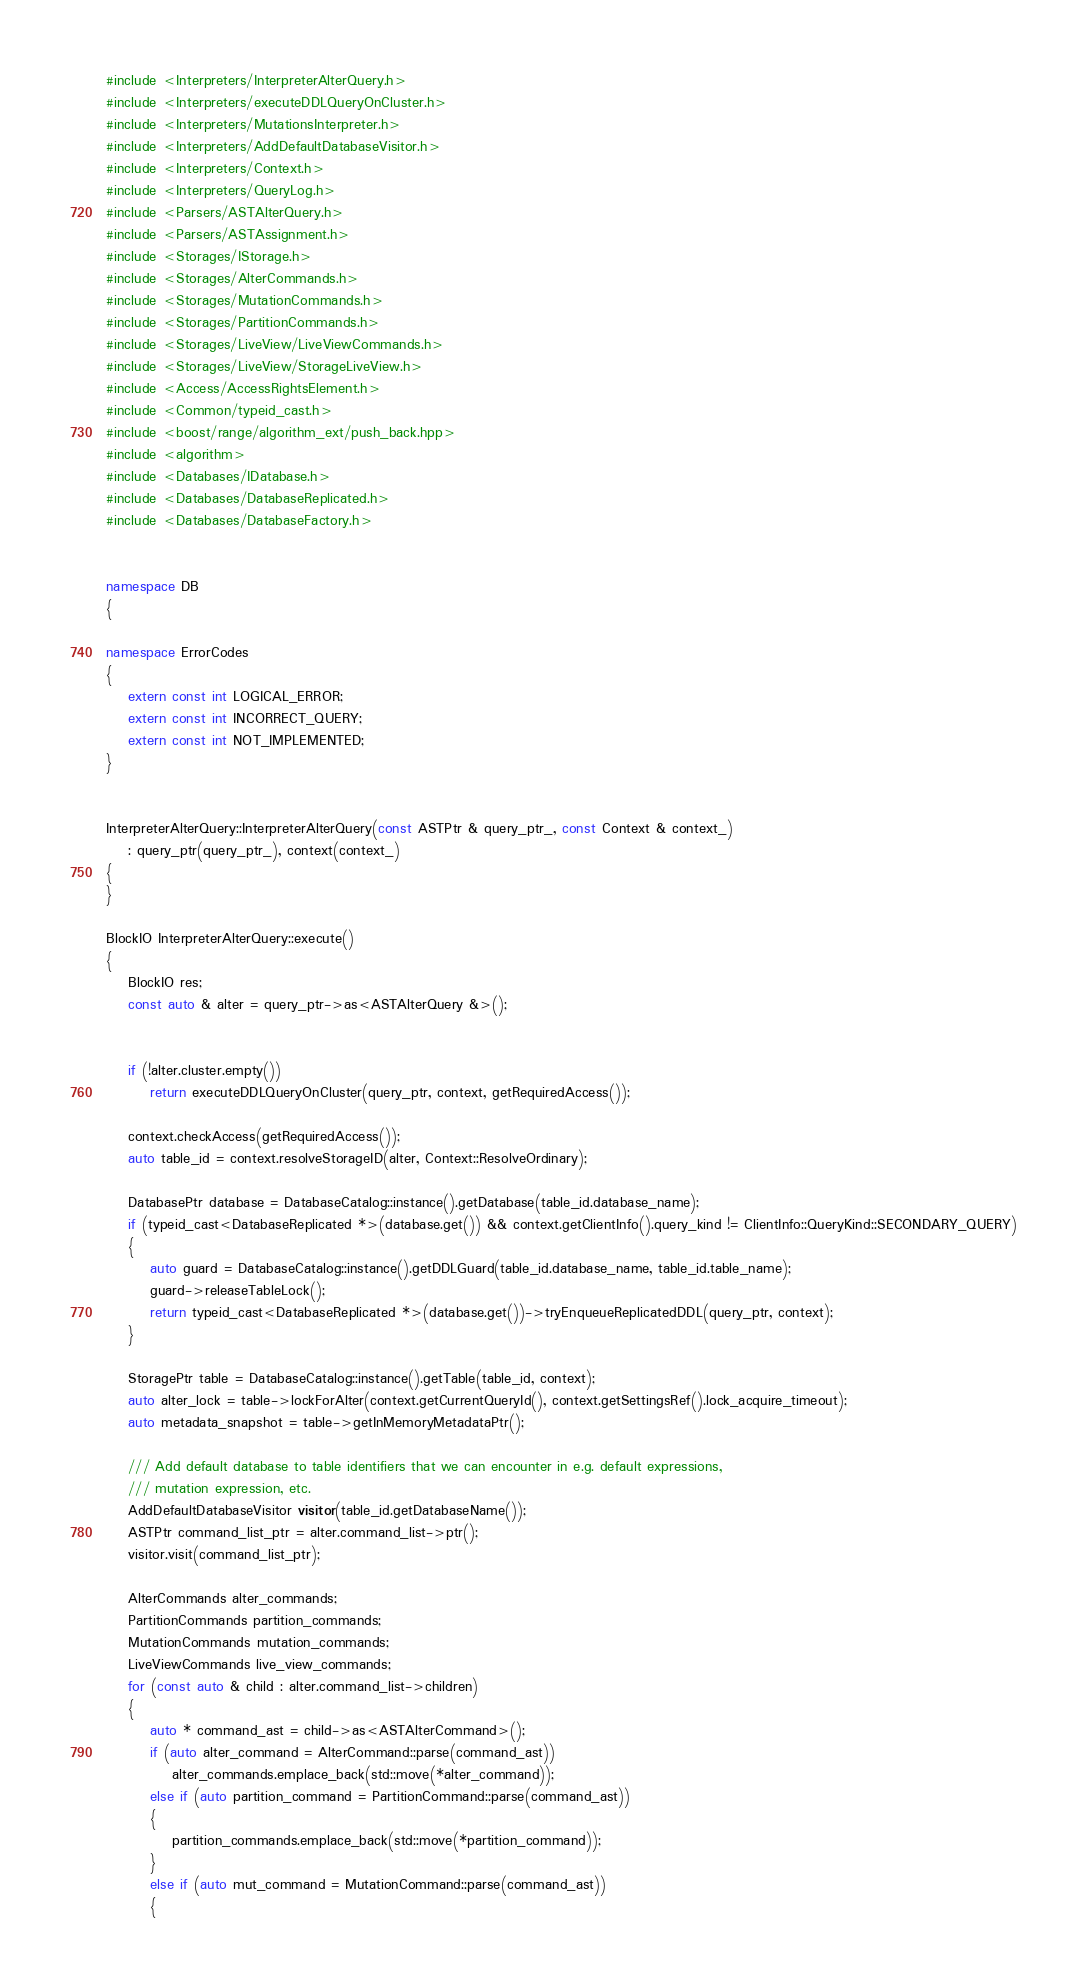Convert code to text. <code><loc_0><loc_0><loc_500><loc_500><_C++_>#include <Interpreters/InterpreterAlterQuery.h>
#include <Interpreters/executeDDLQueryOnCluster.h>
#include <Interpreters/MutationsInterpreter.h>
#include <Interpreters/AddDefaultDatabaseVisitor.h>
#include <Interpreters/Context.h>
#include <Interpreters/QueryLog.h>
#include <Parsers/ASTAlterQuery.h>
#include <Parsers/ASTAssignment.h>
#include <Storages/IStorage.h>
#include <Storages/AlterCommands.h>
#include <Storages/MutationCommands.h>
#include <Storages/PartitionCommands.h>
#include <Storages/LiveView/LiveViewCommands.h>
#include <Storages/LiveView/StorageLiveView.h>
#include <Access/AccessRightsElement.h>
#include <Common/typeid_cast.h>
#include <boost/range/algorithm_ext/push_back.hpp>
#include <algorithm>
#include <Databases/IDatabase.h>
#include <Databases/DatabaseReplicated.h>
#include <Databases/DatabaseFactory.h>


namespace DB
{

namespace ErrorCodes
{
    extern const int LOGICAL_ERROR;
    extern const int INCORRECT_QUERY;
    extern const int NOT_IMPLEMENTED;
}


InterpreterAlterQuery::InterpreterAlterQuery(const ASTPtr & query_ptr_, const Context & context_)
    : query_ptr(query_ptr_), context(context_)
{
}

BlockIO InterpreterAlterQuery::execute()
{
    BlockIO res;
    const auto & alter = query_ptr->as<ASTAlterQuery &>();


    if (!alter.cluster.empty())
        return executeDDLQueryOnCluster(query_ptr, context, getRequiredAccess());

    context.checkAccess(getRequiredAccess());
    auto table_id = context.resolveStorageID(alter, Context::ResolveOrdinary);

    DatabasePtr database = DatabaseCatalog::instance().getDatabase(table_id.database_name);
    if (typeid_cast<DatabaseReplicated *>(database.get()) && context.getClientInfo().query_kind != ClientInfo::QueryKind::SECONDARY_QUERY)
    {
        auto guard = DatabaseCatalog::instance().getDDLGuard(table_id.database_name, table_id.table_name);
        guard->releaseTableLock();
        return typeid_cast<DatabaseReplicated *>(database.get())->tryEnqueueReplicatedDDL(query_ptr, context);
    }

    StoragePtr table = DatabaseCatalog::instance().getTable(table_id, context);
    auto alter_lock = table->lockForAlter(context.getCurrentQueryId(), context.getSettingsRef().lock_acquire_timeout);
    auto metadata_snapshot = table->getInMemoryMetadataPtr();

    /// Add default database to table identifiers that we can encounter in e.g. default expressions,
    /// mutation expression, etc.
    AddDefaultDatabaseVisitor visitor(table_id.getDatabaseName());
    ASTPtr command_list_ptr = alter.command_list->ptr();
    visitor.visit(command_list_ptr);

    AlterCommands alter_commands;
    PartitionCommands partition_commands;
    MutationCommands mutation_commands;
    LiveViewCommands live_view_commands;
    for (const auto & child : alter.command_list->children)
    {
        auto * command_ast = child->as<ASTAlterCommand>();
        if (auto alter_command = AlterCommand::parse(command_ast))
            alter_commands.emplace_back(std::move(*alter_command));
        else if (auto partition_command = PartitionCommand::parse(command_ast))
        {
            partition_commands.emplace_back(std::move(*partition_command));
        }
        else if (auto mut_command = MutationCommand::parse(command_ast))
        {</code> 